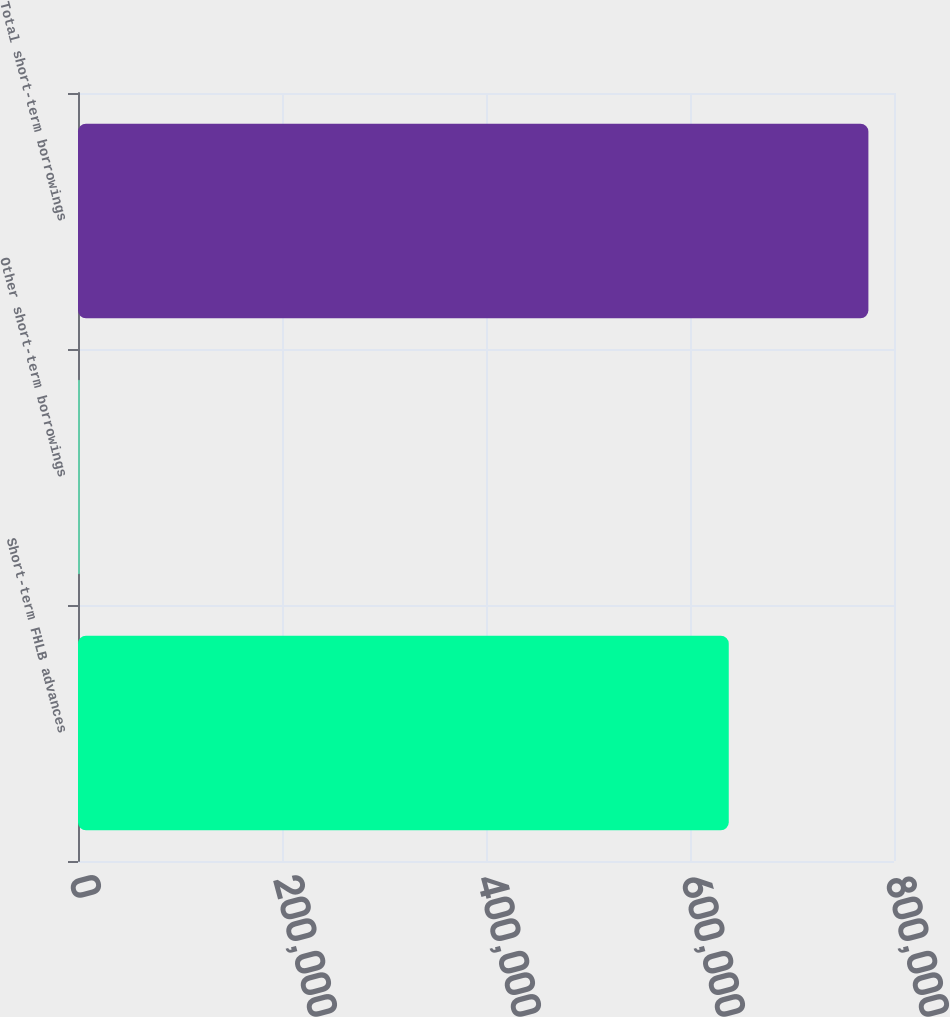<chart> <loc_0><loc_0><loc_500><loc_500><bar_chart><fcel>Short-term FHLB advances<fcel>Other short-term borrowings<fcel>Total short-term borrowings<nl><fcel>638000<fcel>1900<fcel>774900<nl></chart> 